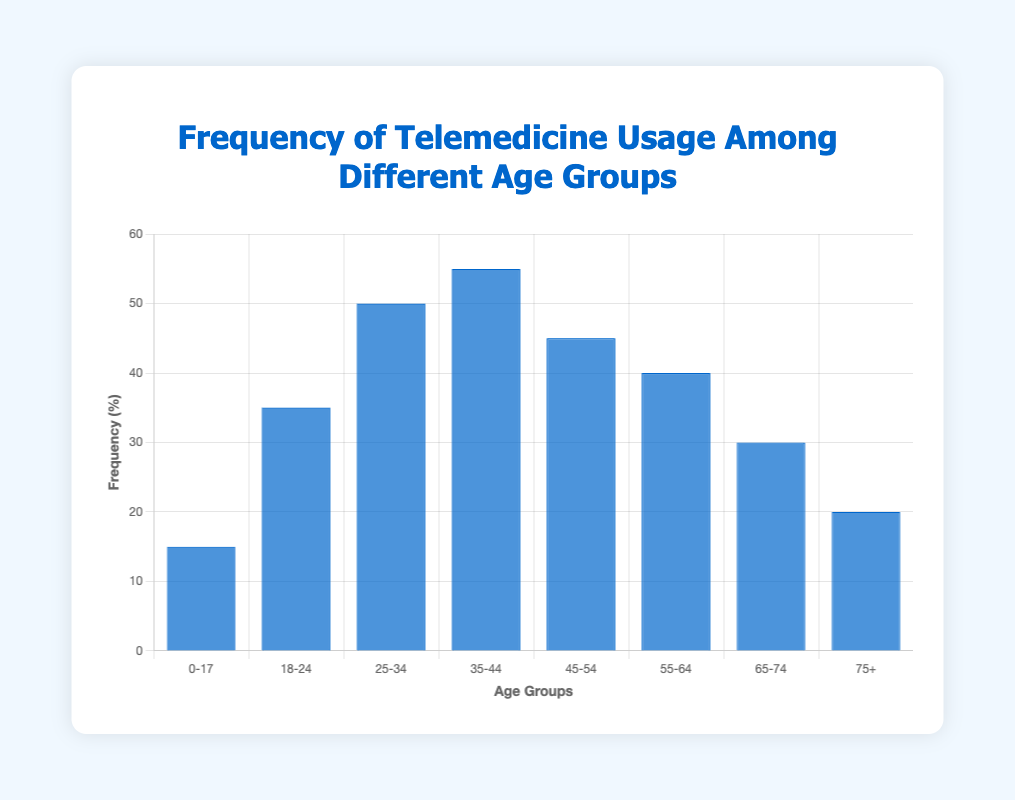Which age group uses telemedicine the most? The height of the bar representing the age group 35-44 is the highest among all the bars. Hence, this age group has the highest frequency of telemedicine usage.
Answer: 35-44 Which age group has the lowest frequency of telemedicine usage? The shortest bar, representing the age group 0-17, indicates the lowest frequency of telemedicine usage.
Answer: 0-17 How much greater is the frequency of telemedicine usage in the 35-44 age group compared to the 0-17 age group? The frequency for 35-44 is 55%, and for 0-17, it is 15%. The difference is calculated as 55% - 15% = 40%.
Answer: 40% What is the combined frequency of telemedicine usage for the age groups under 25? The frequencies for the age groups 0-17 and 18-24 are 15% and 35%, respectively. Combined, it is 15% + 35% = 50%.
Answer: 50% Are the frequencies of telemedicine usage for the age groups 55-64 and 65-74 equal? The heights of the bars for the 55-64 and 65-74 age groups are different. Specifically, the frequency is 40% for the 55-64 age group and 30% for the 65-74 age group. Therefore, they are not equal.
Answer: No Which age group has a frequency of telemedicine usage closest to 50%? The bars for age groups 25-34 and 45-54 both have frequencies close to 50%, with 50% and 45%, respectively. The 25-34 age group is exactly 50%.
Answer: 25-34 What is the average frequency of telemedicine usage across all age groups? The sum of the frequencies for all age groups is 15 + 35 + 50 + 55 + 45 + 40 + 30 + 20 = 290%. There are 8 age groups, so the average is 290% / 8 = 36.25%.
Answer: 36.25% How does the usage frequency of the 75+ age group compare with the 18-24 age group? The frequency for the 75+ age group is 20%, and for the 18-24 age group, it is 35%. The 75+ age group's frequency is therefore lower.
Answer: Lower 